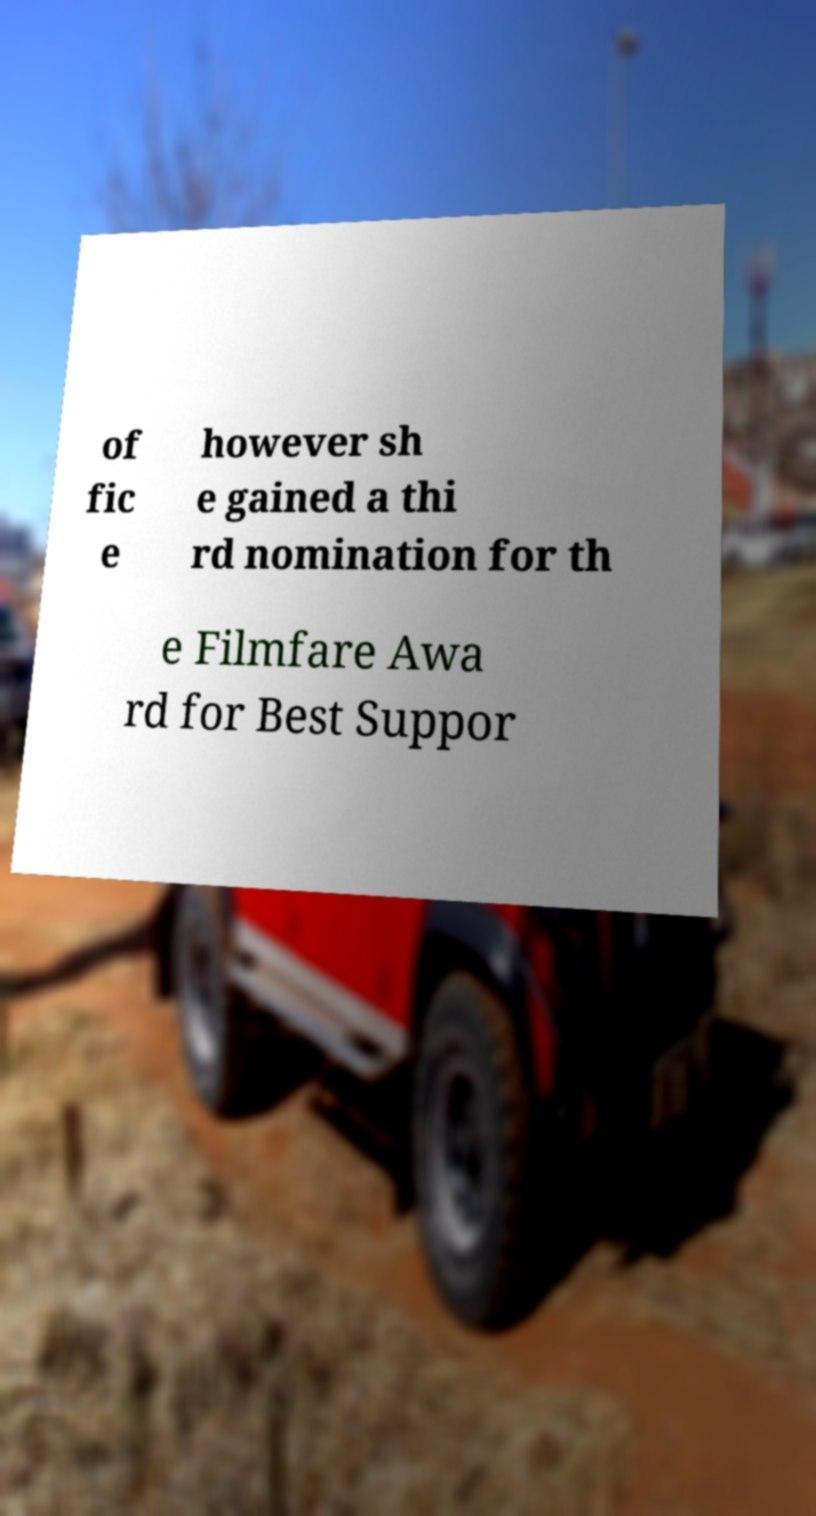Please identify and transcribe the text found in this image. of fic e however sh e gained a thi rd nomination for th e Filmfare Awa rd for Best Suppor 